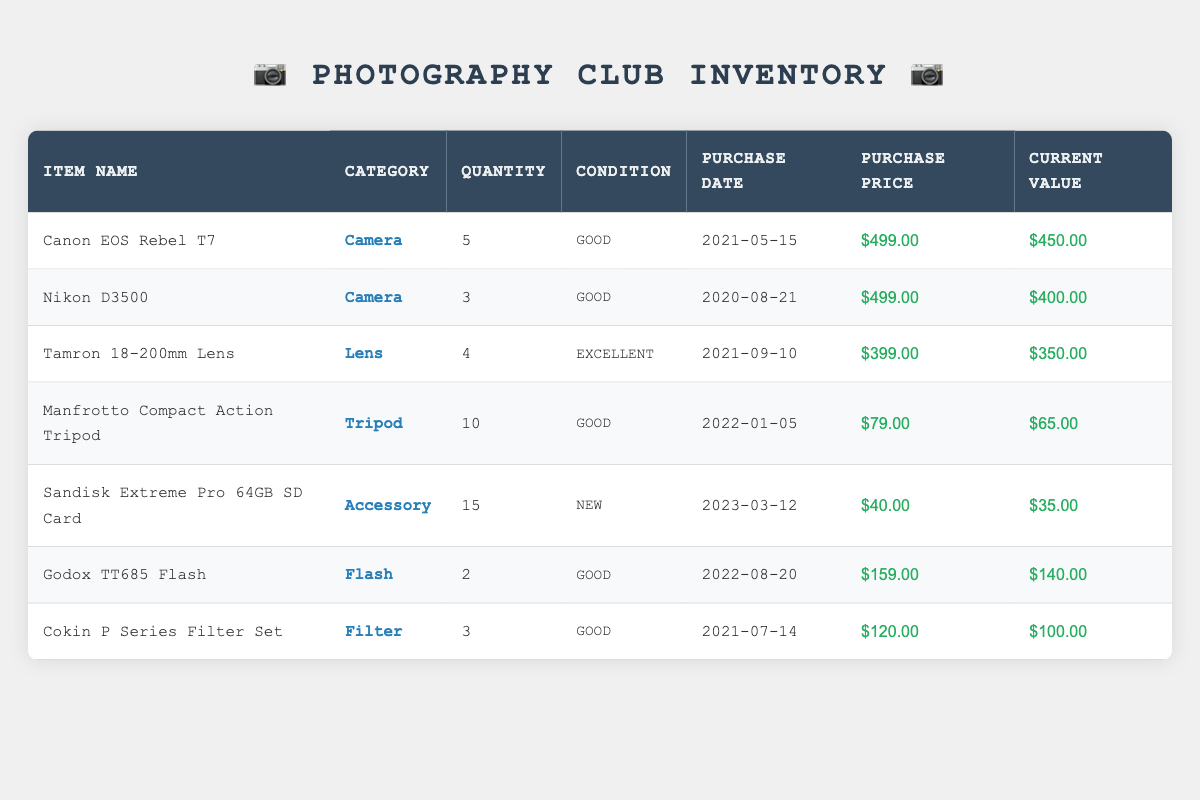What is the total quantity of cameras in the inventory? There are two types of cameras listed: Canon EOS Rebel T7 with a quantity of 5 and Nikon D3500 with a quantity of 3. Adding these gives us 5 + 3 = 8.
Answer: 8 What is the current value of the Sandisk Extreme Pro 64GB SD Card? The table shows that the current value for the Sandisk Extreme Pro 64GB SD Card is listed as $35.00.
Answer: $35.00 Are there any items in the inventory that are in "Excellent" condition? The Tamron 18-200mm Lens is the only item listed with a condition of "Excellent." This can be confirmed by looking at the condition column.
Answer: Yes What is the difference in purchase price between the Canon EOS Rebel T7 and the Nikon D3500? The purchase price of the Canon EOS Rebel T7 is $499.00, while the Nikon D3500 is also $499.00. The difference is 499 - 499 = 0.
Answer: 0 How many tripods are available in total? The table lists only one tripod, the Manfrotto Compact Action Tripod, with a quantity of 10. Therefore, the total quantity of tripods is simply the quantity listed.
Answer: 10 What is the average current value of the filters? There is one type of filter in the inventory: the Cokin P Series Filter Set with a current value of $100.00. Since there is only one item, the average current value is the value itself.
Answer: $100.00 Is there any accessory listed in "New" condition? The Sandisk Extreme Pro 64GB SD Card is the only accessory listed in "New" condition, which can be verified by checking the condition column for the accessory category.
Answer: Yes What is the total purchase price for all lenses in the inventory? There is only one lens, the Tamron 18-200mm Lens, priced at $399.00. Thus, the total purchase price for lenses is simply the purchase price of this lens.
Answer: $399.00 How many items are listed in "Good" condition, and what is their combined current value? Four items are listed in "Good" condition (Canon EOS Rebel T7, Nikon D3500, Manfrotto Compact Action Tripod, and Godox TT685 Flash). Their current values are $450.00, $400.00, $65.00, and $140.00, respectively. Adding these together gives us 450 + 400 + 65 + 140 = 1055.
Answer: 4 items, $1055.00 